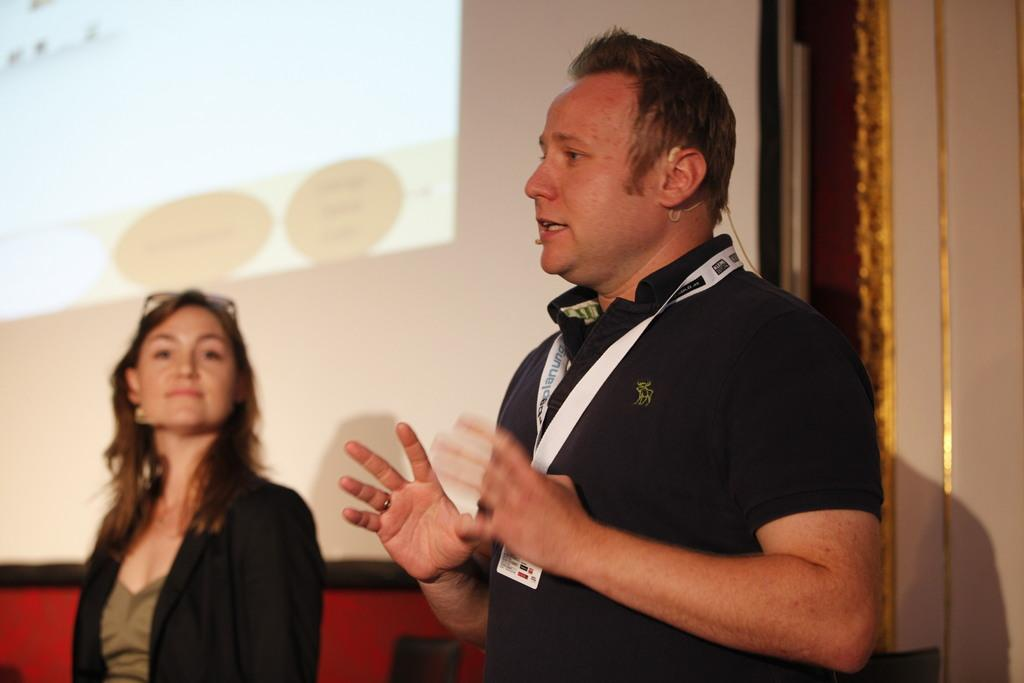How many people are in the image? There are two people in the image, a man and a woman. What are the man and woman doing in the image? The man and woman are standing near a projector screen. Where is the projector screen located in the image? The projector screen is attached to a wall. What type of pie is being served on the table in the image? There is no table or pie present in the image; it features a man, a woman, and a projector screen attached to a wall. 